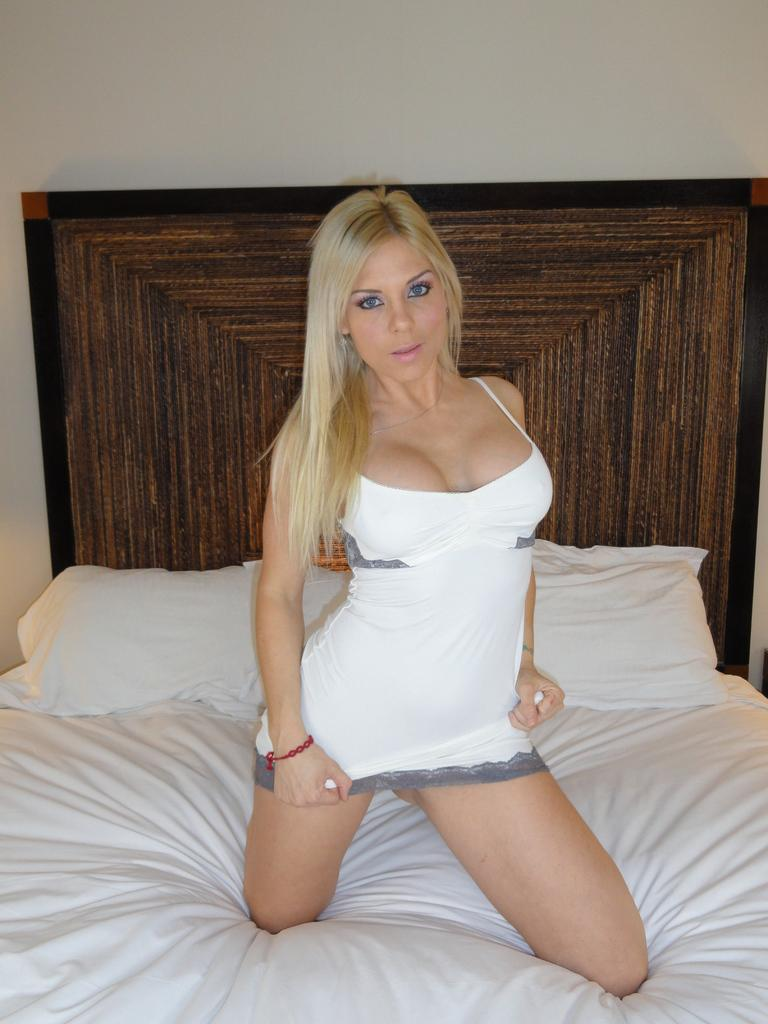Who is the main subject in the image? There is a lady in the image. What is the lady wearing? The lady is wearing a white dress. What is the lady sitting on? The lady is sitting on a white bed. How many spots can be seen on the lady's dress in the image? There are no spots visible on the lady's dress in the image; it is a solid white dress. 